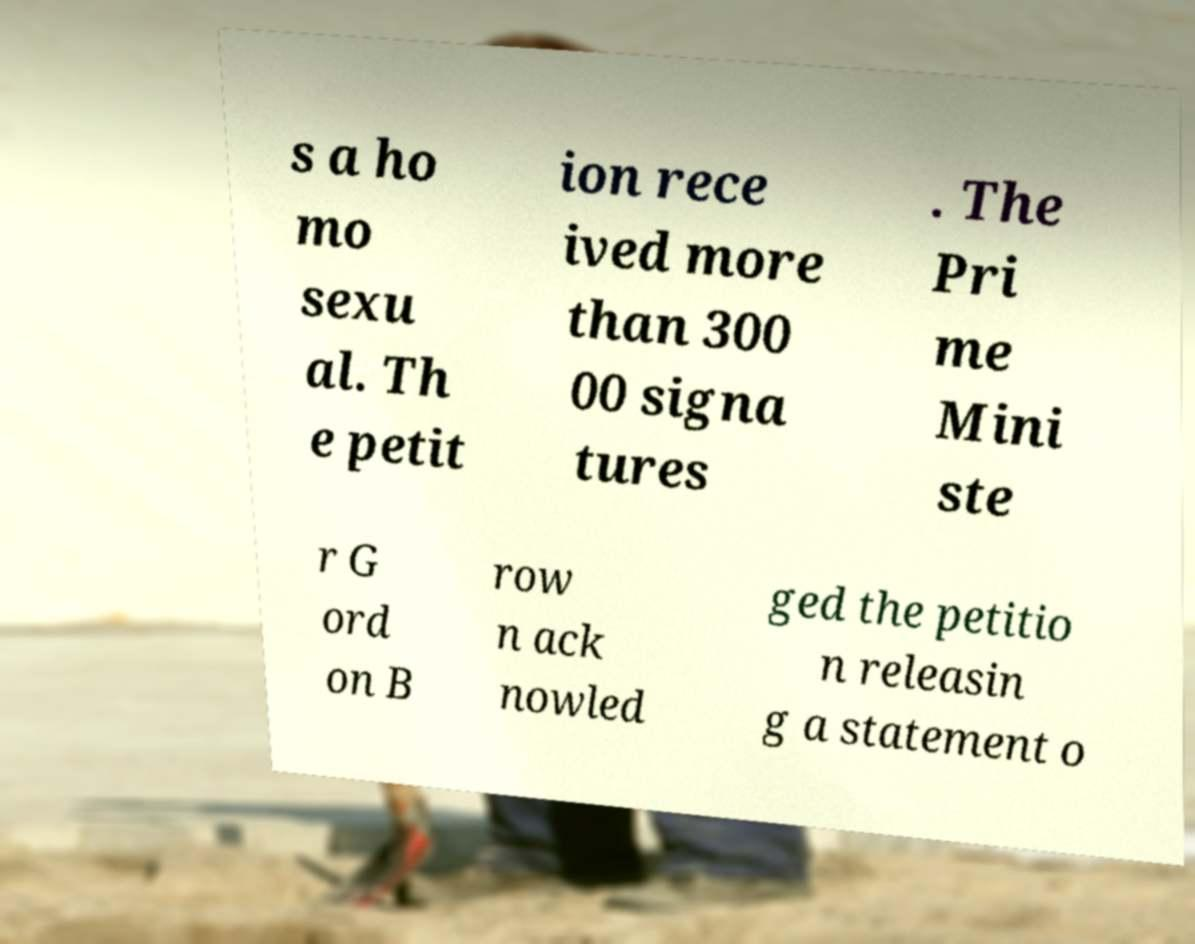Could you assist in decoding the text presented in this image and type it out clearly? s a ho mo sexu al. Th e petit ion rece ived more than 300 00 signa tures . The Pri me Mini ste r G ord on B row n ack nowled ged the petitio n releasin g a statement o 